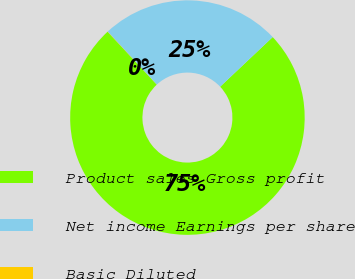Convert chart. <chart><loc_0><loc_0><loc_500><loc_500><pie_chart><fcel>Product sales Gross profit<fcel>Net income Earnings per share<fcel>Basic Diluted<nl><fcel>75.12%<fcel>24.85%<fcel>0.03%<nl></chart> 